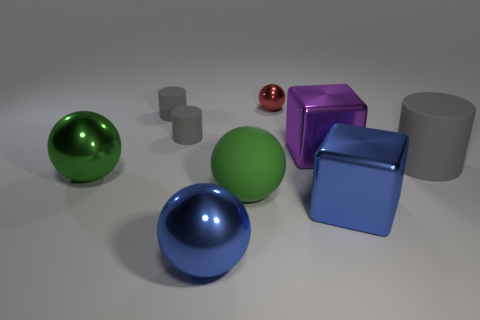There is another ball that is the same color as the large rubber sphere; what is it made of?
Give a very brief answer. Metal. There is another green thing that is the same shape as the big green shiny thing; what is it made of?
Offer a very short reply. Rubber. There is a metallic sphere in front of the large green metallic sphere; is its color the same as the large block that is in front of the big purple thing?
Give a very brief answer. Yes. The purple metal object is what shape?
Provide a short and direct response. Cube. Are there more big green things left of the red object than large purple cylinders?
Give a very brief answer. Yes. There is a gray rubber object on the right side of the small red thing; what shape is it?
Your response must be concise. Cylinder. What number of other things are the same shape as the tiny red metal thing?
Provide a short and direct response. 3. Do the green sphere that is on the left side of the green matte thing and the blue ball have the same material?
Keep it short and to the point. Yes. Is the number of big balls that are behind the large green rubber thing the same as the number of big blue objects in front of the big blue cube?
Ensure brevity in your answer.  Yes. How big is the shiny sphere that is in front of the large rubber sphere?
Give a very brief answer. Large. 